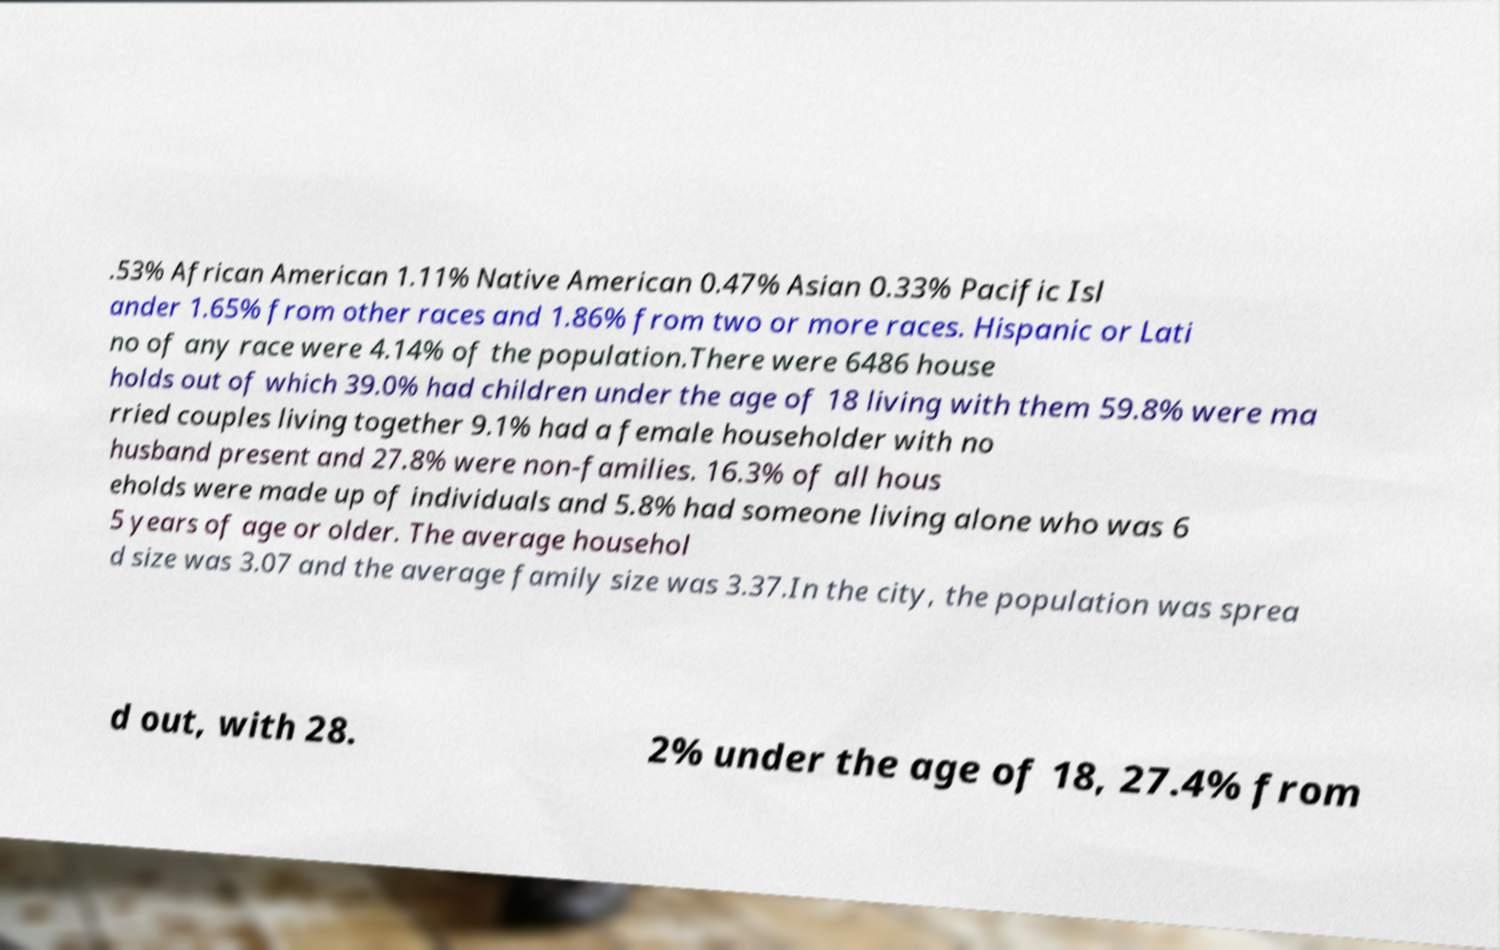Please identify and transcribe the text found in this image. .53% African American 1.11% Native American 0.47% Asian 0.33% Pacific Isl ander 1.65% from other races and 1.86% from two or more races. Hispanic or Lati no of any race were 4.14% of the population.There were 6486 house holds out of which 39.0% had children under the age of 18 living with them 59.8% were ma rried couples living together 9.1% had a female householder with no husband present and 27.8% were non-families. 16.3% of all hous eholds were made up of individuals and 5.8% had someone living alone who was 6 5 years of age or older. The average househol d size was 3.07 and the average family size was 3.37.In the city, the population was sprea d out, with 28. 2% under the age of 18, 27.4% from 